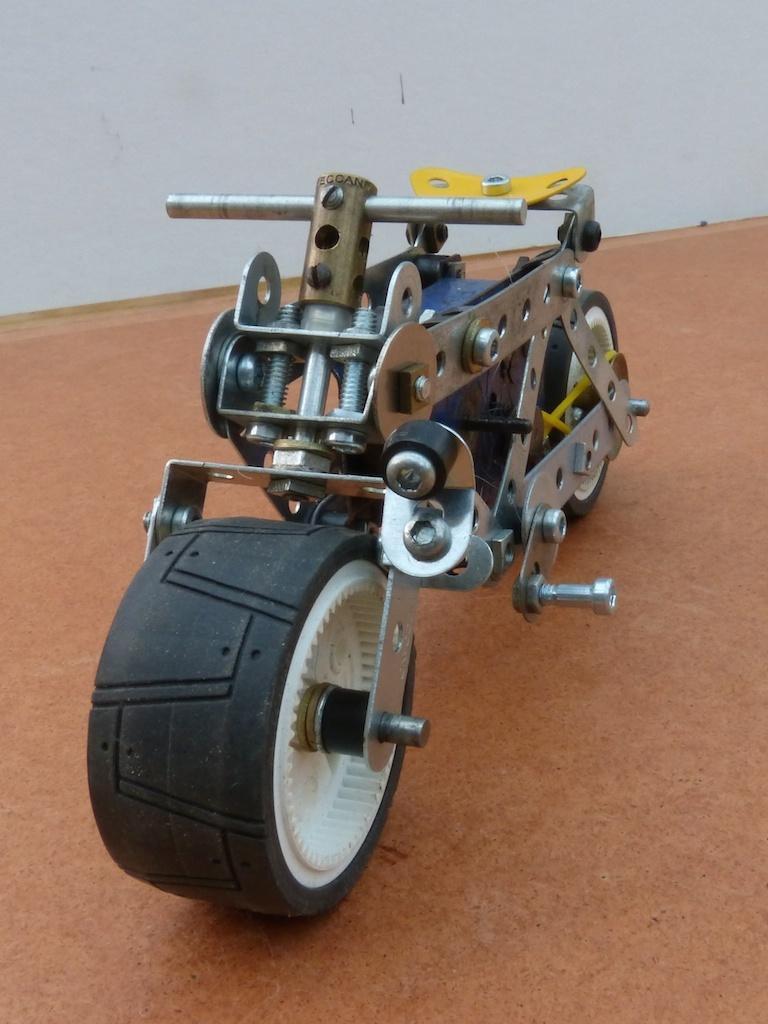Please provide a concise description of this image. In this image there is a toy motorbike on the wooden board, and in the background there is a wall. 